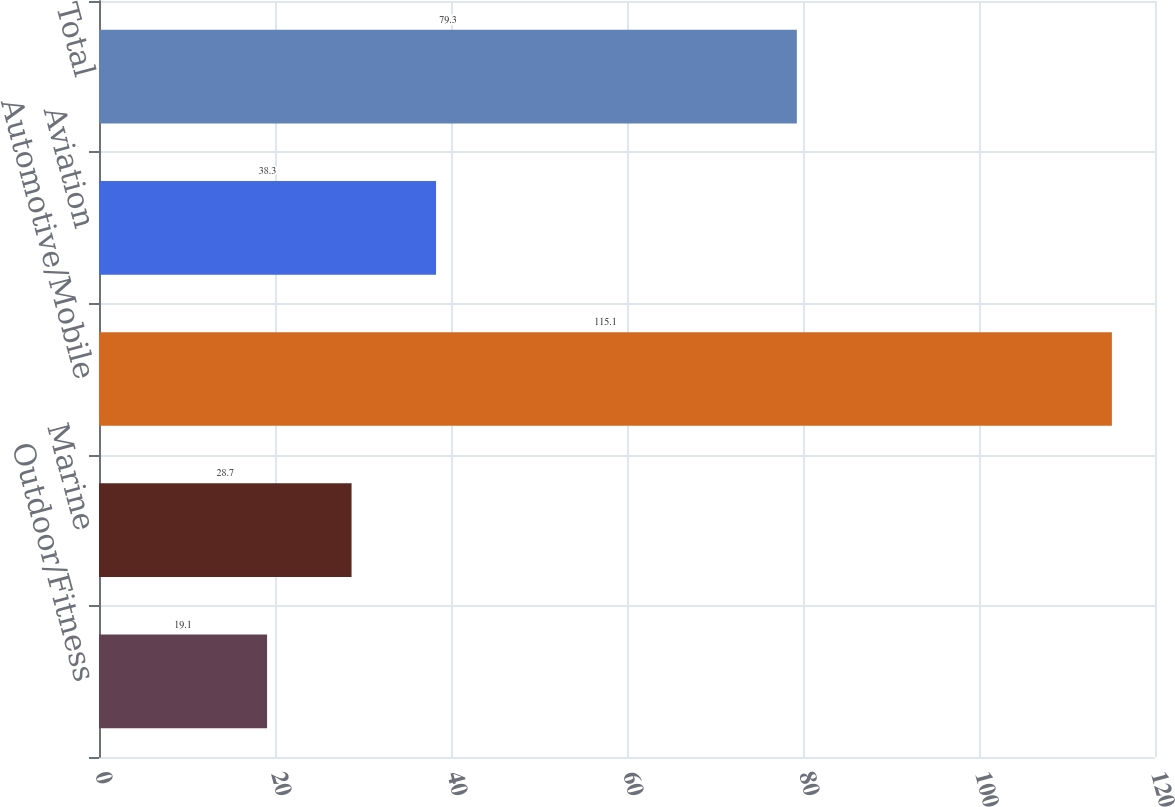Convert chart to OTSL. <chart><loc_0><loc_0><loc_500><loc_500><bar_chart><fcel>Outdoor/Fitness<fcel>Marine<fcel>Automotive/Mobile<fcel>Aviation<fcel>Total<nl><fcel>19.1<fcel>28.7<fcel>115.1<fcel>38.3<fcel>79.3<nl></chart> 